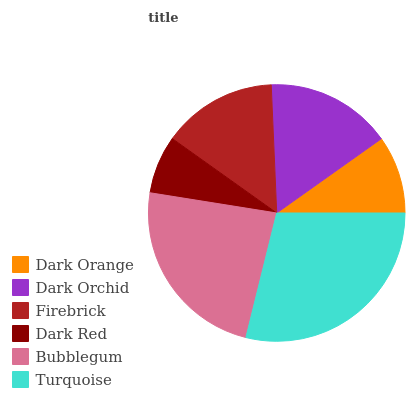Is Dark Red the minimum?
Answer yes or no. Yes. Is Turquoise the maximum?
Answer yes or no. Yes. Is Dark Orchid the minimum?
Answer yes or no. No. Is Dark Orchid the maximum?
Answer yes or no. No. Is Dark Orchid greater than Dark Orange?
Answer yes or no. Yes. Is Dark Orange less than Dark Orchid?
Answer yes or no. Yes. Is Dark Orange greater than Dark Orchid?
Answer yes or no. No. Is Dark Orchid less than Dark Orange?
Answer yes or no. No. Is Dark Orchid the high median?
Answer yes or no. Yes. Is Firebrick the low median?
Answer yes or no. Yes. Is Firebrick the high median?
Answer yes or no. No. Is Bubblegum the low median?
Answer yes or no. No. 